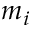Convert formula to latex. <formula><loc_0><loc_0><loc_500><loc_500>m _ { i }</formula> 